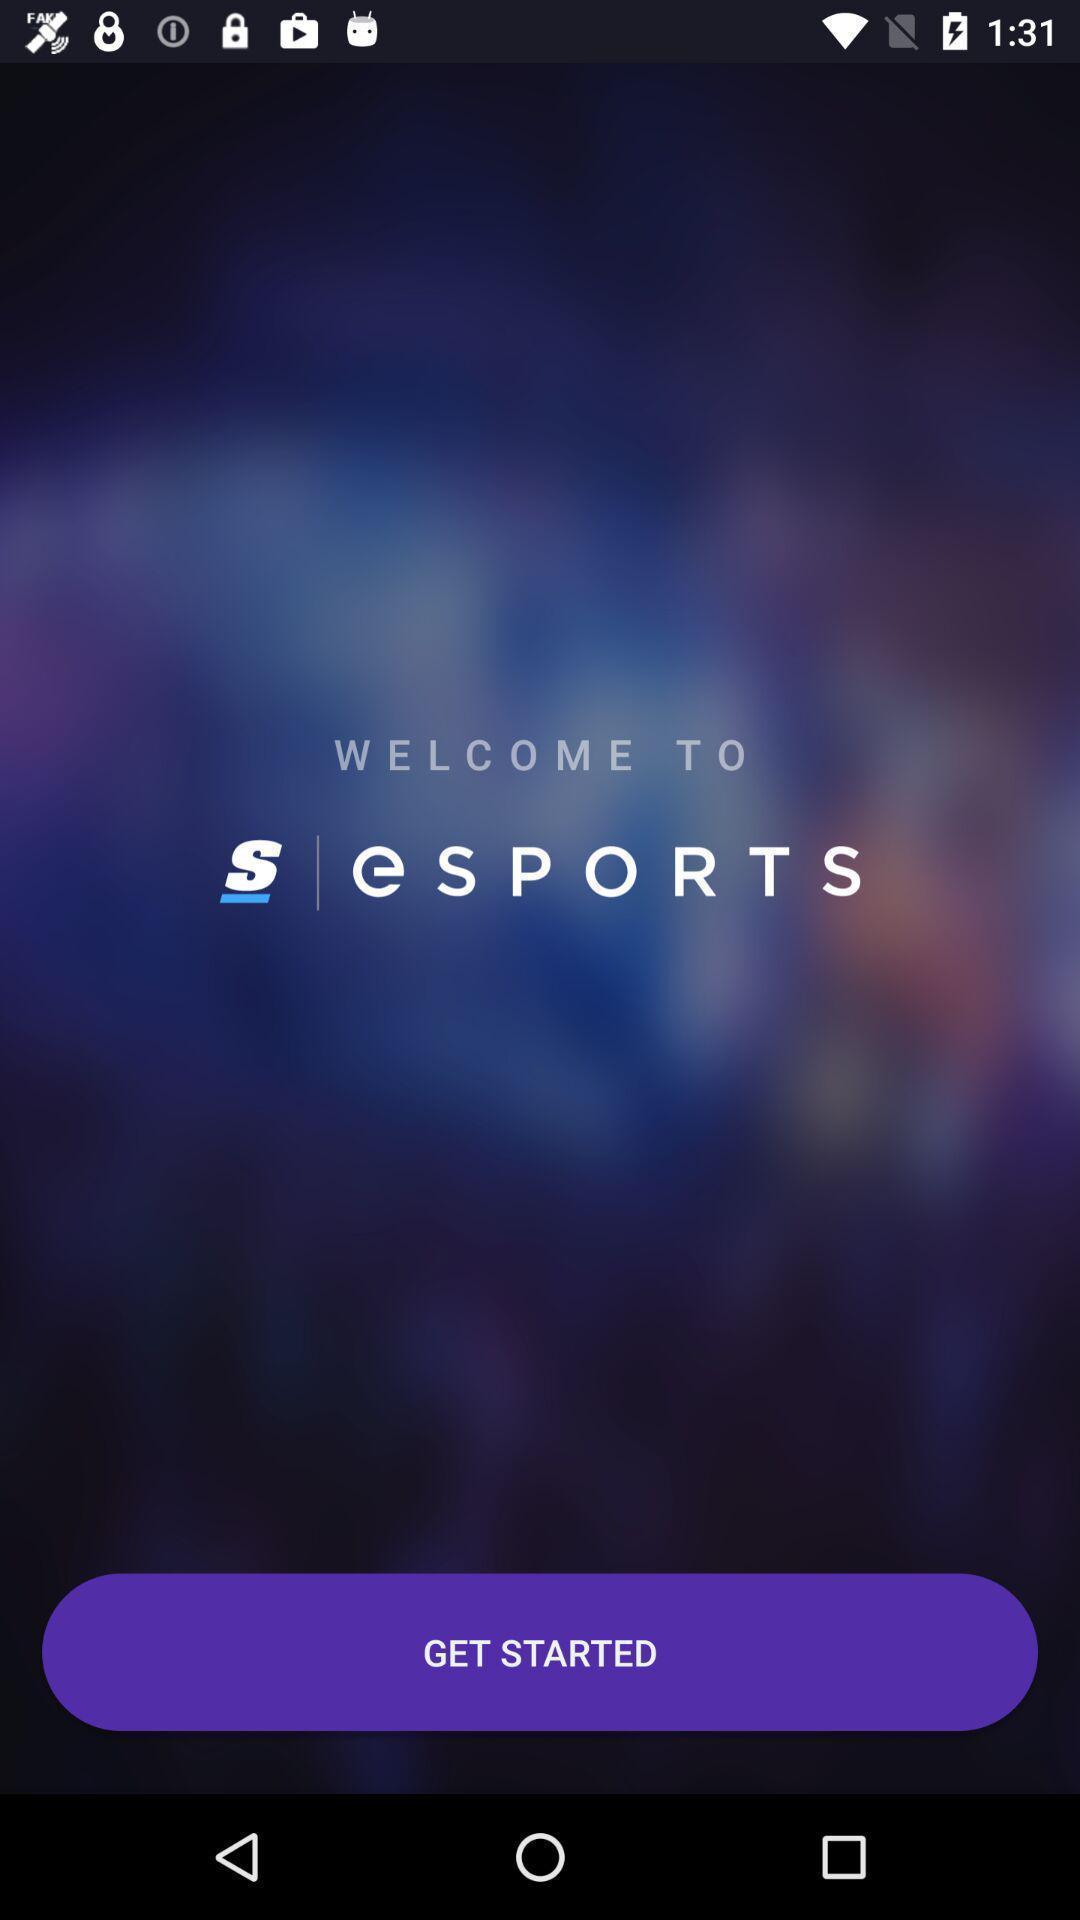Please provide a description for this image. Welcome page to the application. 